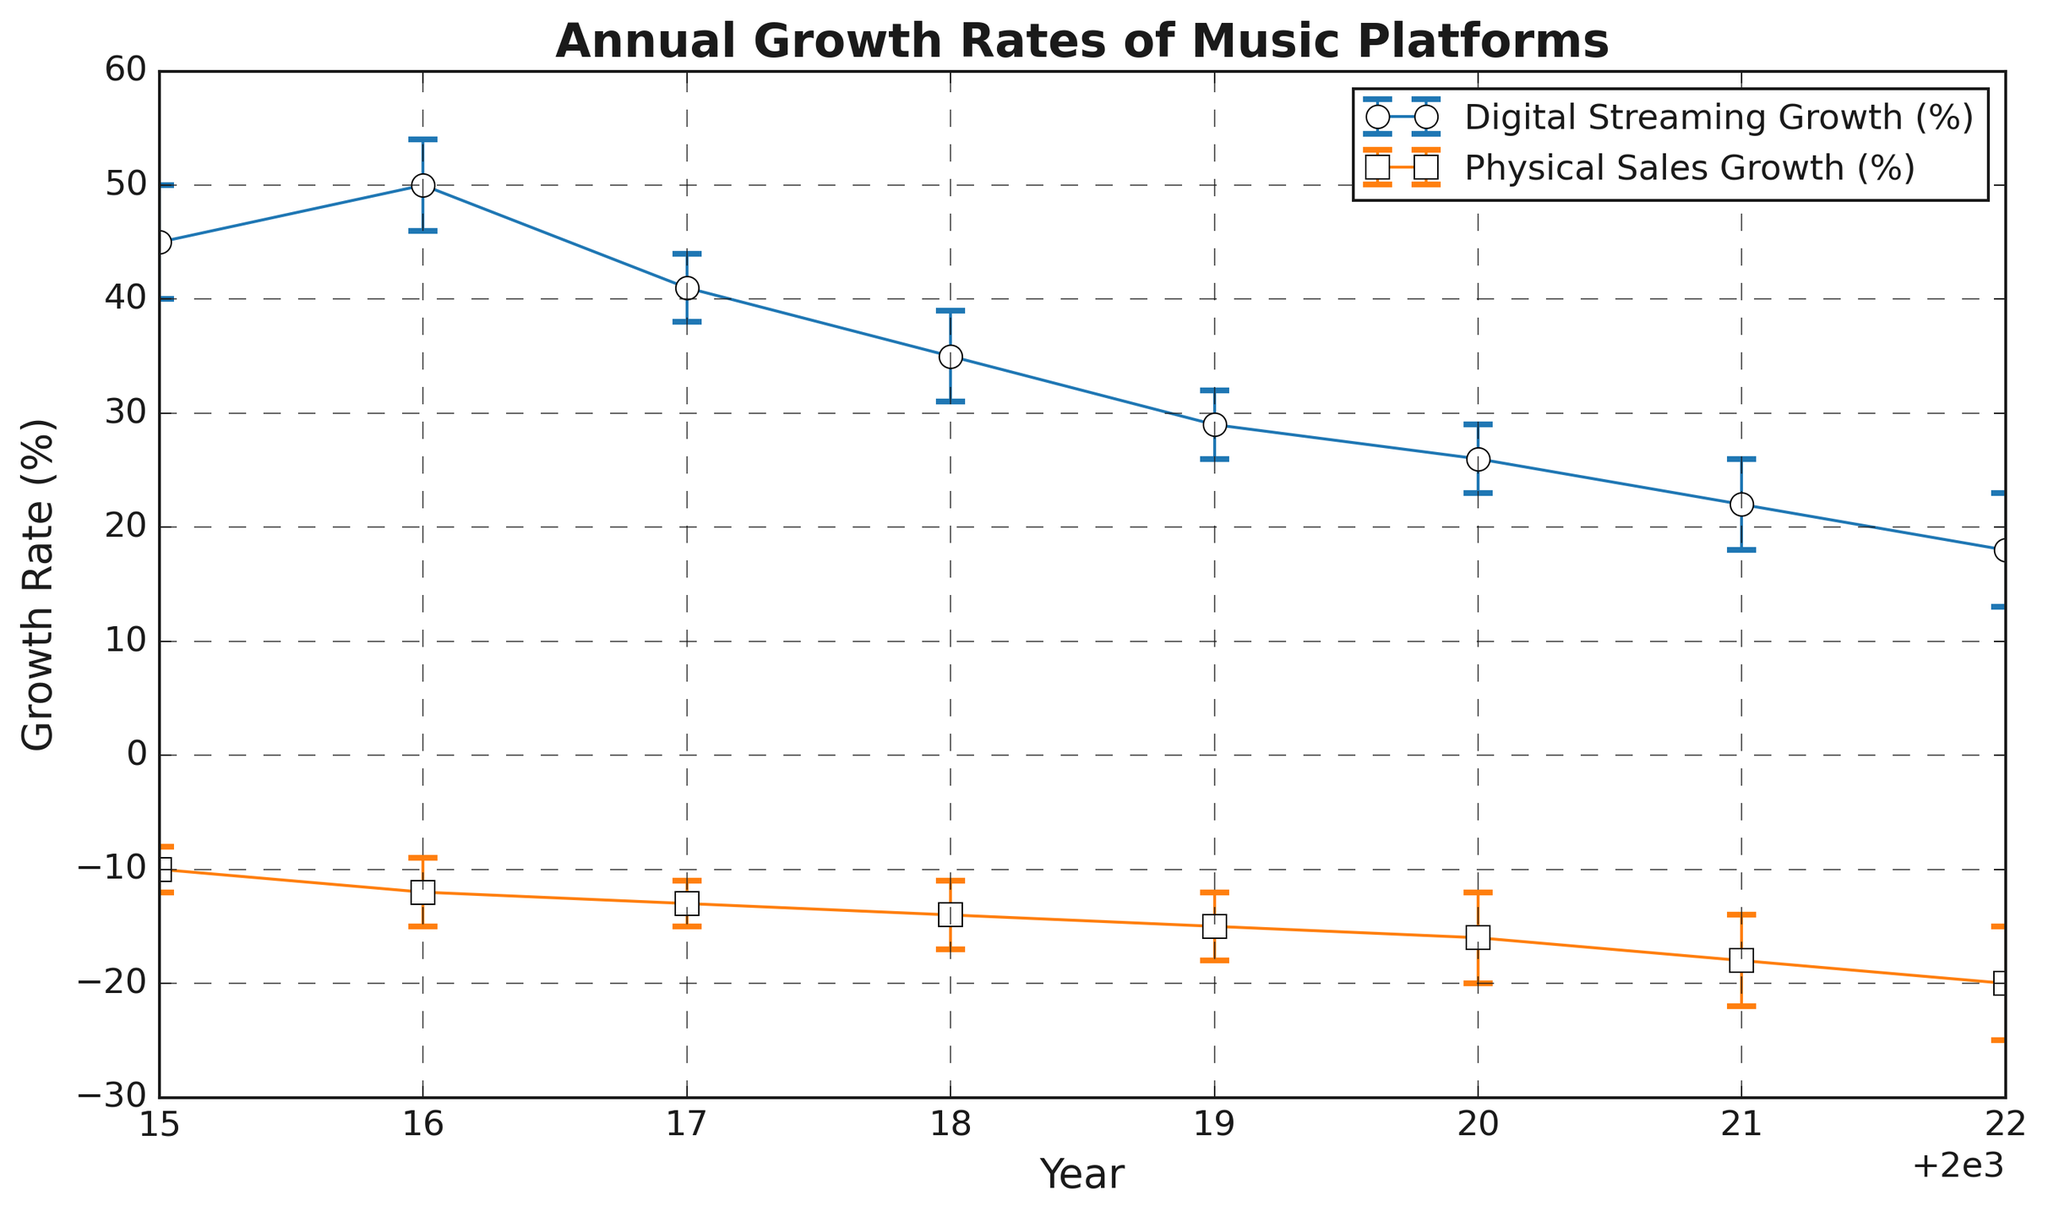What's the difference in growth rates of digital streaming between 2015 and 2022? The growth rate of digital streaming in 2015 is 45%, and in 2022 it is 18%. The difference is 45% - 18%.
Answer: 27% Which year shows the maximum volatility in physical sales growth? The volatility in physical sales growth is represented by the error bars. By comparing the error values for each year, the maximum is ±5% in 2022.
Answer: 2022 Did the digital streaming growth rate decrease consistently each year over the given period? By observing the trend line of digital streaming growth, from 2015 to 2022, the growth rate decreases each year without interruptions.
Answer: Yes Compare the growth rates and their volatilities of digital streaming and physical sales in 2020. Digital streaming growth in 2020 is 26% with a volatility of ±3%, while physical sales growth is -16% with a volatility of ±4%.
Answer: Digital: 26% ±3%, Physical: -16% ±4% What is the average annual growth rate of digital streaming from 2015 to 2022? Summing the digital streaming growth rates for each year (45 + 50 + 41 + 35 + 29 + 26 + 22 + 18) and dividing by 8 (years): (45 + 50 + 41 + 35 + 29 + 26 + 22 + 18) / 8 = 33.25%
Answer: 33.25% How does the error in digital streaming growth compare to physical sales growth over the years? Comparing the error values for digital and physical growth each year: 5 (digital) compared to 2 (physical) in 2015, 4 vs 3 in 2016, 3 vs 2 in 2017, 4 vs 3 in 2018, 3 vs 3 in 2019, 3 vs 4 in 2020, 4 vs 4 in 2021, 5 vs 5 in 2022. In early years, digital growth error is higher; in later years, the errors converge.
Answer: Digital higher initially, converges over time In which year did physical sales experience the largest decline, based on the data? Physical sales showed the most significant decline in the year with the most negative growth rate, which is -20% in 2022.
Answer: 2022 What's the combined market volatility for digital streaming and physical sales in 2018? The error values for digital streaming and physical sales in 2018 are ±4% and ±3%, respectively. Combined volatility is calculated as ±(4% + 3%) = ±7%.
Answer: ±7% 